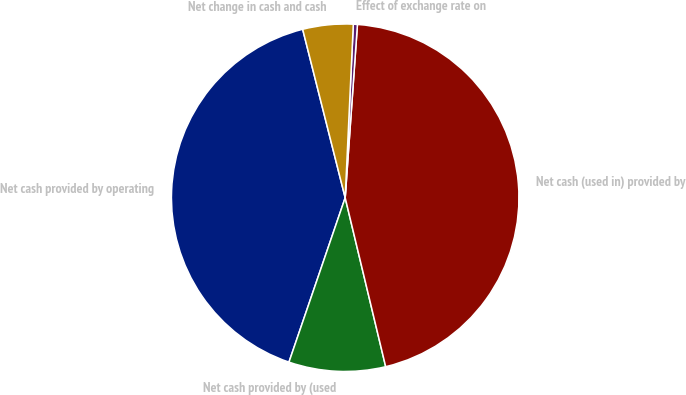Convert chart to OTSL. <chart><loc_0><loc_0><loc_500><loc_500><pie_chart><fcel>Net cash provided by operating<fcel>Net cash provided by (used<fcel>Net cash (used in) provided by<fcel>Effect of exchange rate on<fcel>Net change in cash and cash<nl><fcel>40.82%<fcel>8.99%<fcel>45.13%<fcel>0.38%<fcel>4.68%<nl></chart> 